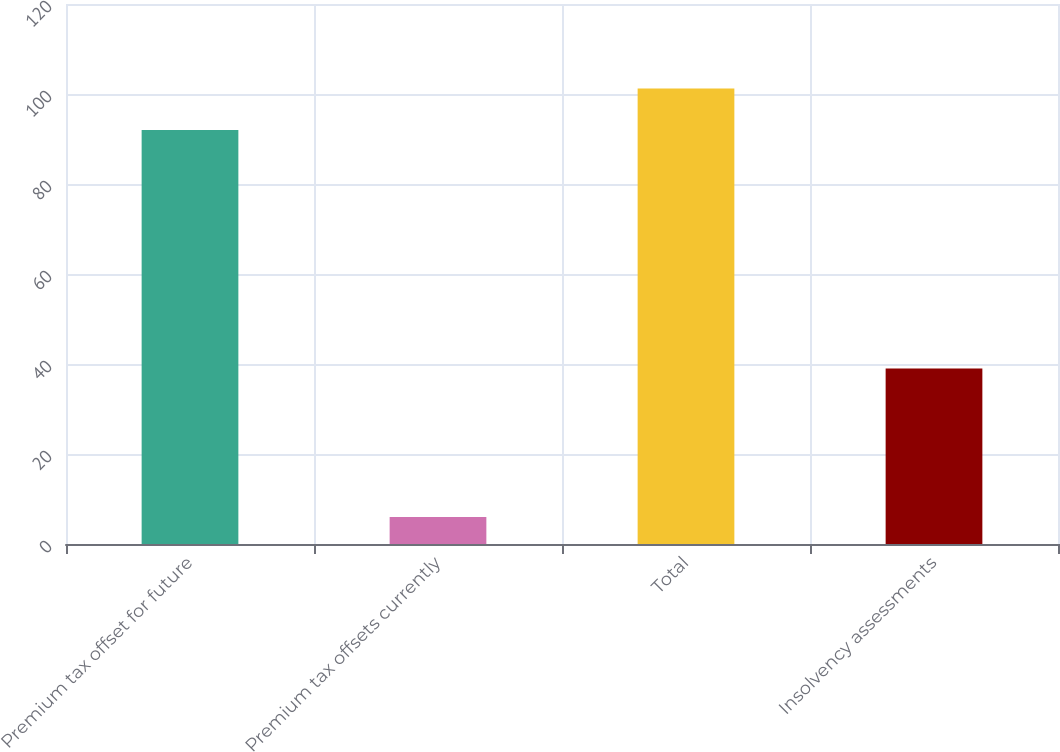<chart> <loc_0><loc_0><loc_500><loc_500><bar_chart><fcel>Premium tax offset for future<fcel>Premium tax offsets currently<fcel>Total<fcel>Insolvency assessments<nl><fcel>92<fcel>6<fcel>101.2<fcel>39<nl></chart> 